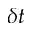<formula> <loc_0><loc_0><loc_500><loc_500>\delta t</formula> 